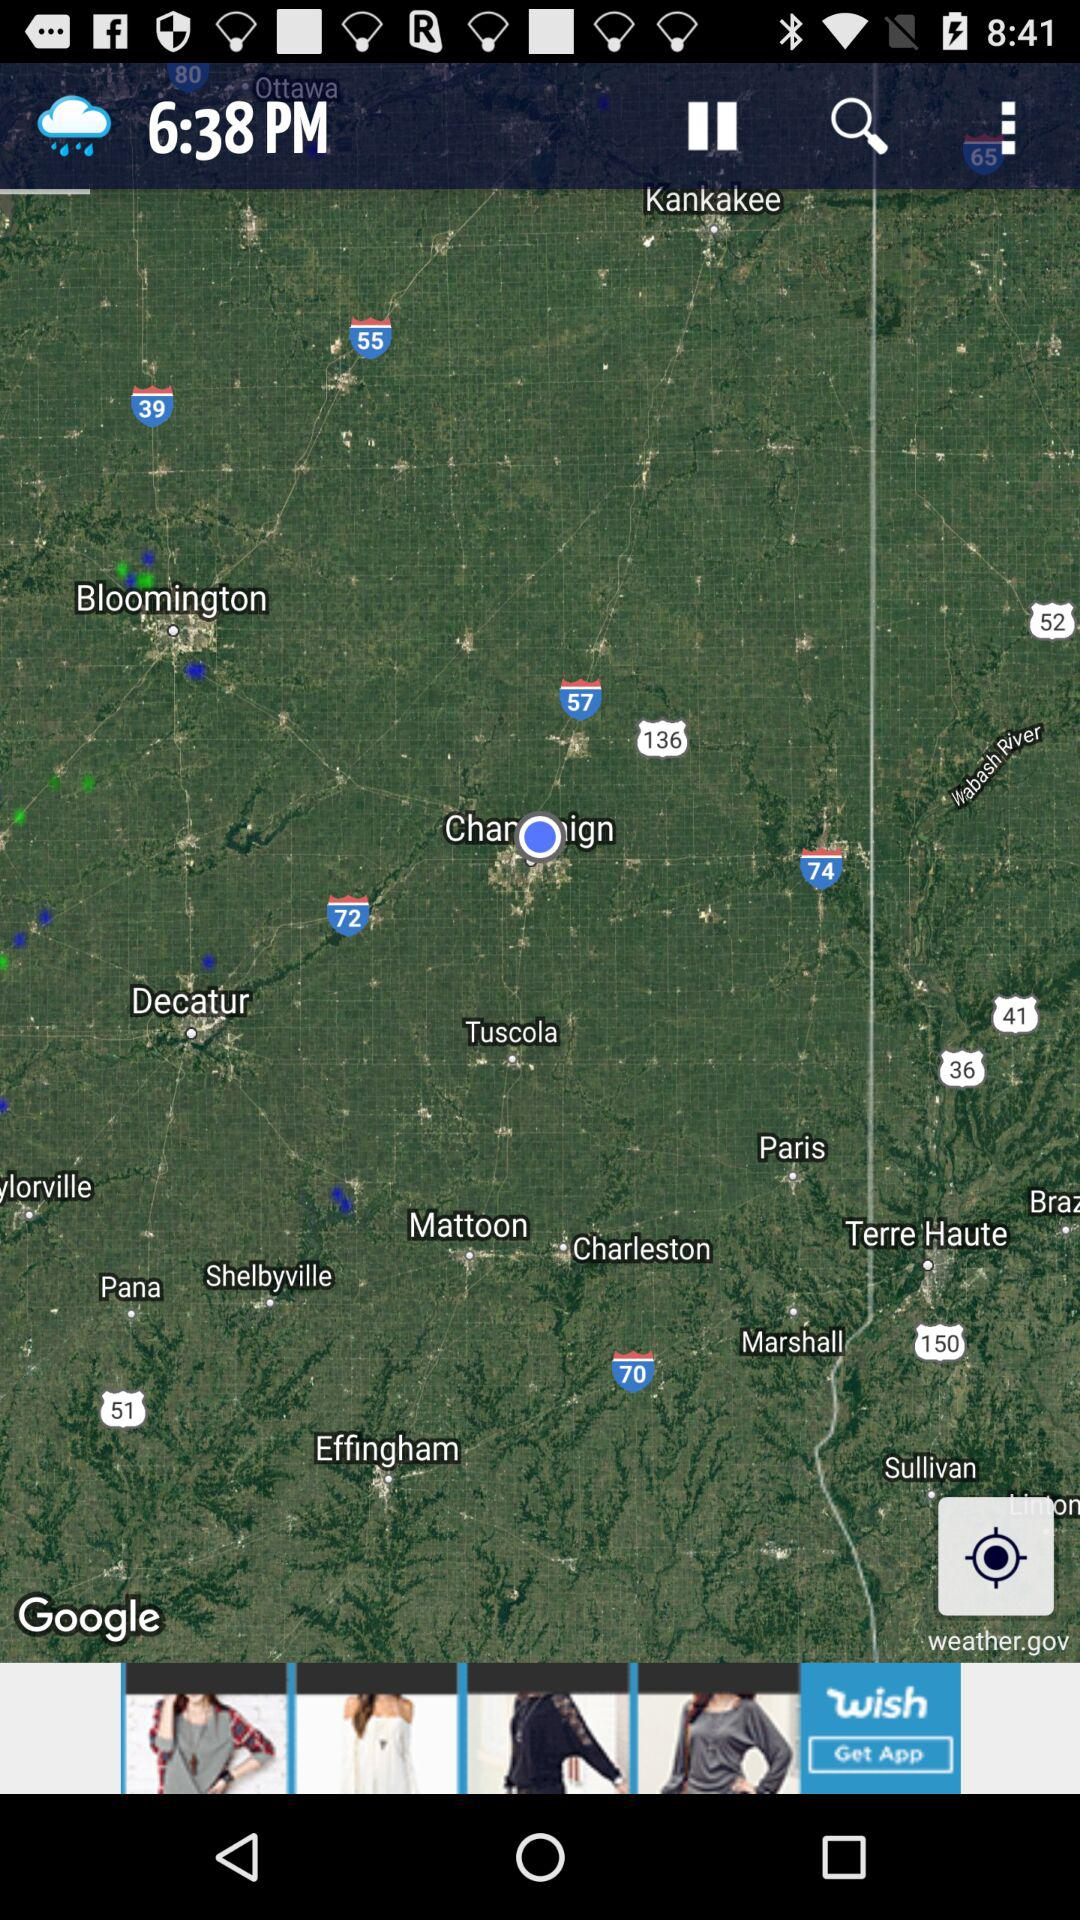How is the weather?
When the provided information is insufficient, respond with <no answer>. <no answer> 